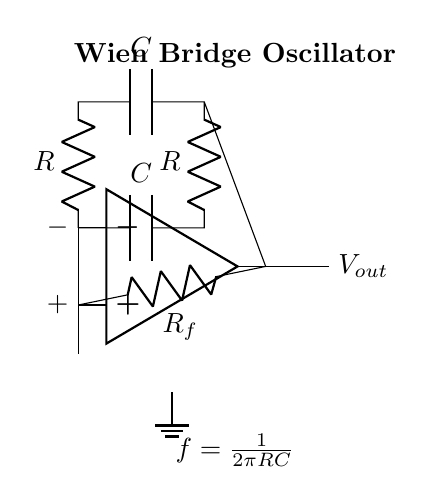What is the type of this circuit? The circuit is a Wien bridge oscillator, which is known for generating sinusoidal waveforms. This is indicated by the configuration of the operational amplifier and the RC network.
Answer: Wien bridge oscillator What components are used in the feedback loop? The feedback loop contains a resistor denoted as R_f, and the Wien bridge network consists of two resistors and one capacitor, noted in the circuit as R and C. This arrangement is crucial for frequency selectivity in the oscillator.
Answer: R_f, R, C What is the frequency formula represented in this circuit? The frequency formula displayed in the circuit is f = 1 / (2πRC), which relates the frequency of oscillation to the resistor and capacitor in the network. This formula is critical for understanding how to set the frequency of oscillation.
Answer: f = 1 / (2πRC) How many capacitors are present in the circuit? There are two capacitors in this circuit, each labeled as C. One of them is in the feedback route while the other component of the Wien bridge is also a capacitor, serving the function of setting the frequency characteristics of the oscillator.
Answer: 2 What role does the op-amp play in this circuit? The operational amplifier functions as the active element that amplifies the signal and sustains oscillations in the circuit. It creates a positive feedback loop with the Wien bridge network to maintain oscillation at the desired frequency.
Answer: Amplification What defines the feedback resistance in this oscillator circuit? The feedback resistance is established by the resistor R_f positioned between the output of the op-amp and its non-inverting input. This resistor is crucial for maintaining the balance of the oscillation and preventing distortion.
Answer: R_f What connection is made to the ground in the circuit? The ground is connected to the inverting input of the op-amp, indicating a reference point for the circuit. This helps stabilize the circuit and ensures accurate voltage levels are maintained throughout the oscillation process.
Answer: Inverting input connection 